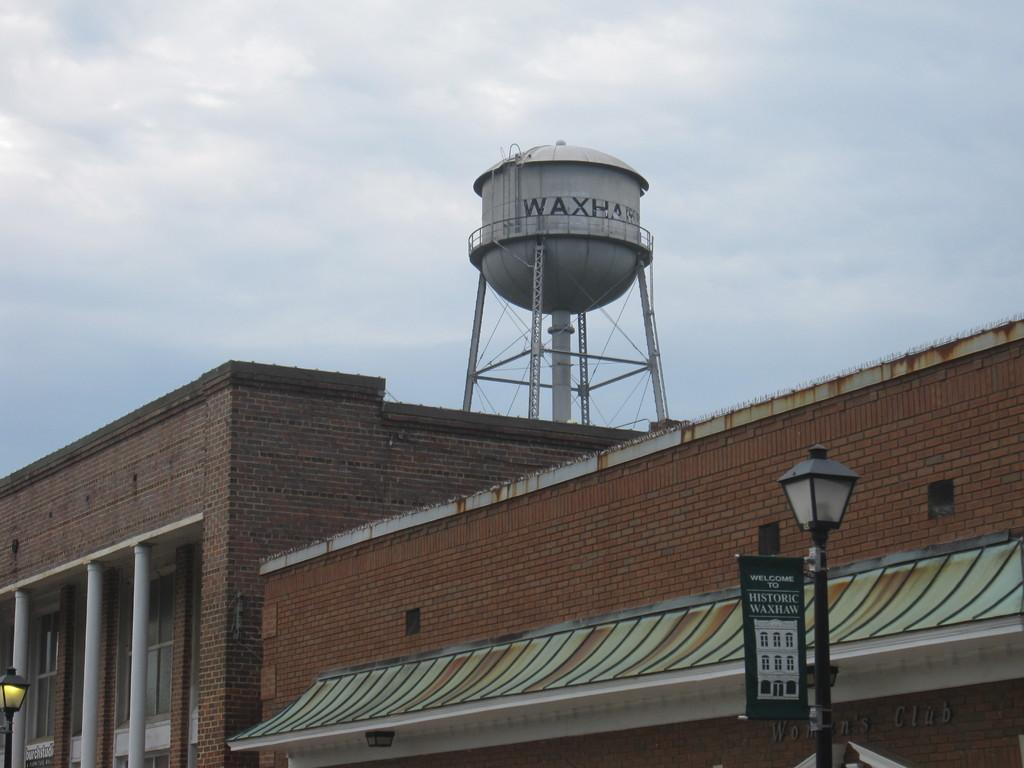What type of structures can be seen in the image? There are street lights and a building with pillars in the image. What is on top of the building? There is a tank on the building. What can be seen in the background of the image? The sky is visible in the background of the image. What flavor of jam is being spread on the tramp in the image? There is no jam or tramp present in the image. 